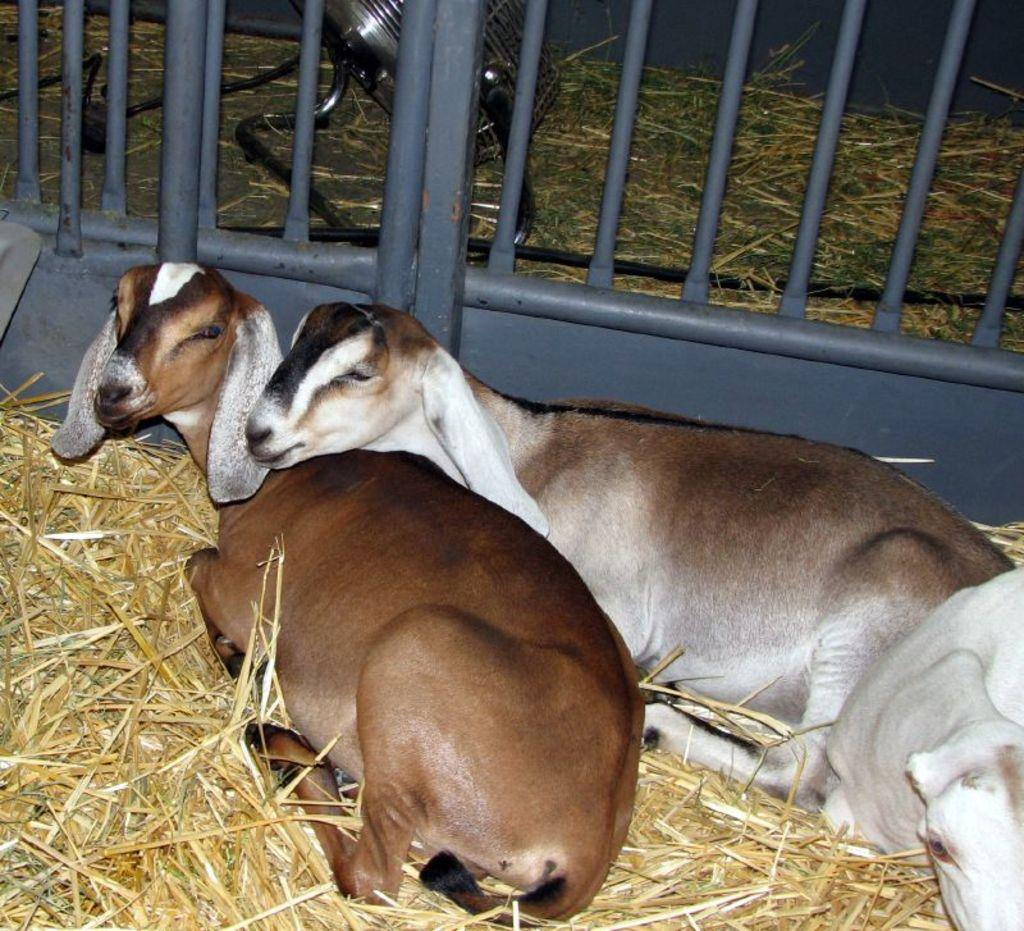What color is the grass in the image? The grass in the image is yellow. What type of structure can be seen in the image? There are iron bars in the image. What animals are present in the image? There are goats in the image. What colors do the goats have? The goats have white and brown colors. Can you tell me where the berry is located in the image? There is no berry present in the image. How does the goat help the farmer in the image? The image does not show any interaction between the goats and a farmer, so it cannot be determined how the goat might help. 